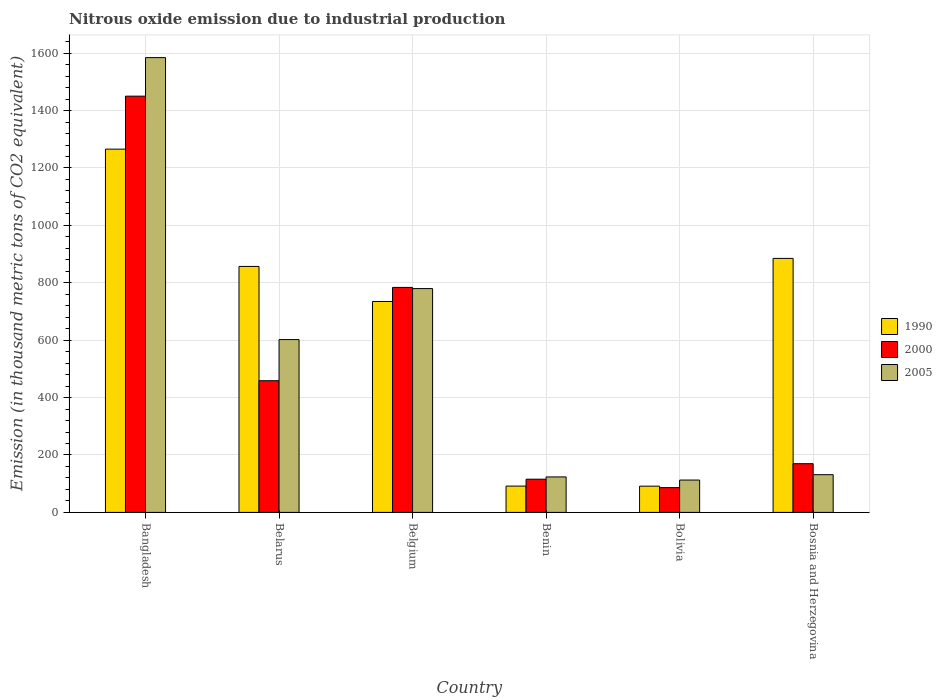Are the number of bars per tick equal to the number of legend labels?
Your answer should be compact. Yes. Are the number of bars on each tick of the X-axis equal?
Provide a short and direct response. Yes. How many bars are there on the 4th tick from the left?
Provide a short and direct response. 3. What is the amount of nitrous oxide emitted in 1990 in Bolivia?
Provide a succinct answer. 91.4. Across all countries, what is the maximum amount of nitrous oxide emitted in 2005?
Provide a short and direct response. 1584.6. Across all countries, what is the minimum amount of nitrous oxide emitted in 1990?
Your answer should be compact. 91.4. What is the total amount of nitrous oxide emitted in 2005 in the graph?
Your answer should be very brief. 3334.2. What is the difference between the amount of nitrous oxide emitted in 2000 in Bangladesh and that in Benin?
Your response must be concise. 1334.6. What is the difference between the amount of nitrous oxide emitted in 1990 in Bolivia and the amount of nitrous oxide emitted in 2000 in Bosnia and Herzegovina?
Offer a very short reply. -78.3. What is the average amount of nitrous oxide emitted in 2000 per country?
Keep it short and to the point. 510.78. What is the difference between the amount of nitrous oxide emitted of/in 1990 and amount of nitrous oxide emitted of/in 2000 in Benin?
Ensure brevity in your answer.  -24. In how many countries, is the amount of nitrous oxide emitted in 1990 greater than 1040 thousand metric tons?
Keep it short and to the point. 1. What is the ratio of the amount of nitrous oxide emitted in 1990 in Bangladesh to that in Belgium?
Provide a short and direct response. 1.72. Is the amount of nitrous oxide emitted in 1990 in Belarus less than that in Benin?
Offer a terse response. No. What is the difference between the highest and the second highest amount of nitrous oxide emitted in 2005?
Your answer should be very brief. 982.5. What is the difference between the highest and the lowest amount of nitrous oxide emitted in 1990?
Your answer should be compact. 1174.3. What does the 3rd bar from the left in Bangladesh represents?
Offer a very short reply. 2005. What does the 3rd bar from the right in Benin represents?
Your answer should be very brief. 1990. Are all the bars in the graph horizontal?
Keep it short and to the point. No. How many countries are there in the graph?
Offer a very short reply. 6. What is the difference between two consecutive major ticks on the Y-axis?
Offer a very short reply. 200. Where does the legend appear in the graph?
Your answer should be very brief. Center right. How many legend labels are there?
Provide a succinct answer. 3. How are the legend labels stacked?
Provide a short and direct response. Vertical. What is the title of the graph?
Provide a succinct answer. Nitrous oxide emission due to industrial production. What is the label or title of the Y-axis?
Provide a short and direct response. Emission (in thousand metric tons of CO2 equivalent). What is the Emission (in thousand metric tons of CO2 equivalent) of 1990 in Bangladesh?
Your answer should be compact. 1265.7. What is the Emission (in thousand metric tons of CO2 equivalent) in 2000 in Bangladesh?
Your answer should be very brief. 1450.3. What is the Emission (in thousand metric tons of CO2 equivalent) in 2005 in Bangladesh?
Offer a terse response. 1584.6. What is the Emission (in thousand metric tons of CO2 equivalent) in 1990 in Belarus?
Your response must be concise. 857. What is the Emission (in thousand metric tons of CO2 equivalent) of 2000 in Belarus?
Keep it short and to the point. 458.8. What is the Emission (in thousand metric tons of CO2 equivalent) in 2005 in Belarus?
Make the answer very short. 602.1. What is the Emission (in thousand metric tons of CO2 equivalent) in 1990 in Belgium?
Your response must be concise. 734.9. What is the Emission (in thousand metric tons of CO2 equivalent) of 2000 in Belgium?
Your answer should be very brief. 783.9. What is the Emission (in thousand metric tons of CO2 equivalent) of 2005 in Belgium?
Keep it short and to the point. 779.8. What is the Emission (in thousand metric tons of CO2 equivalent) in 1990 in Benin?
Provide a succinct answer. 91.7. What is the Emission (in thousand metric tons of CO2 equivalent) in 2000 in Benin?
Provide a succinct answer. 115.7. What is the Emission (in thousand metric tons of CO2 equivalent) in 2005 in Benin?
Your answer should be compact. 123.6. What is the Emission (in thousand metric tons of CO2 equivalent) of 1990 in Bolivia?
Provide a succinct answer. 91.4. What is the Emission (in thousand metric tons of CO2 equivalent) of 2000 in Bolivia?
Your response must be concise. 86.3. What is the Emission (in thousand metric tons of CO2 equivalent) in 2005 in Bolivia?
Give a very brief answer. 112.7. What is the Emission (in thousand metric tons of CO2 equivalent) in 1990 in Bosnia and Herzegovina?
Offer a terse response. 885. What is the Emission (in thousand metric tons of CO2 equivalent) in 2000 in Bosnia and Herzegovina?
Make the answer very short. 169.7. What is the Emission (in thousand metric tons of CO2 equivalent) of 2005 in Bosnia and Herzegovina?
Give a very brief answer. 131.4. Across all countries, what is the maximum Emission (in thousand metric tons of CO2 equivalent) of 1990?
Offer a terse response. 1265.7. Across all countries, what is the maximum Emission (in thousand metric tons of CO2 equivalent) of 2000?
Your answer should be very brief. 1450.3. Across all countries, what is the maximum Emission (in thousand metric tons of CO2 equivalent) in 2005?
Provide a succinct answer. 1584.6. Across all countries, what is the minimum Emission (in thousand metric tons of CO2 equivalent) of 1990?
Give a very brief answer. 91.4. Across all countries, what is the minimum Emission (in thousand metric tons of CO2 equivalent) in 2000?
Make the answer very short. 86.3. Across all countries, what is the minimum Emission (in thousand metric tons of CO2 equivalent) of 2005?
Offer a very short reply. 112.7. What is the total Emission (in thousand metric tons of CO2 equivalent) in 1990 in the graph?
Ensure brevity in your answer.  3925.7. What is the total Emission (in thousand metric tons of CO2 equivalent) of 2000 in the graph?
Your answer should be very brief. 3064.7. What is the total Emission (in thousand metric tons of CO2 equivalent) in 2005 in the graph?
Provide a succinct answer. 3334.2. What is the difference between the Emission (in thousand metric tons of CO2 equivalent) of 1990 in Bangladesh and that in Belarus?
Ensure brevity in your answer.  408.7. What is the difference between the Emission (in thousand metric tons of CO2 equivalent) in 2000 in Bangladesh and that in Belarus?
Make the answer very short. 991.5. What is the difference between the Emission (in thousand metric tons of CO2 equivalent) in 2005 in Bangladesh and that in Belarus?
Offer a terse response. 982.5. What is the difference between the Emission (in thousand metric tons of CO2 equivalent) of 1990 in Bangladesh and that in Belgium?
Make the answer very short. 530.8. What is the difference between the Emission (in thousand metric tons of CO2 equivalent) of 2000 in Bangladesh and that in Belgium?
Keep it short and to the point. 666.4. What is the difference between the Emission (in thousand metric tons of CO2 equivalent) in 2005 in Bangladesh and that in Belgium?
Your answer should be compact. 804.8. What is the difference between the Emission (in thousand metric tons of CO2 equivalent) in 1990 in Bangladesh and that in Benin?
Your response must be concise. 1174. What is the difference between the Emission (in thousand metric tons of CO2 equivalent) in 2000 in Bangladesh and that in Benin?
Keep it short and to the point. 1334.6. What is the difference between the Emission (in thousand metric tons of CO2 equivalent) of 2005 in Bangladesh and that in Benin?
Keep it short and to the point. 1461. What is the difference between the Emission (in thousand metric tons of CO2 equivalent) of 1990 in Bangladesh and that in Bolivia?
Ensure brevity in your answer.  1174.3. What is the difference between the Emission (in thousand metric tons of CO2 equivalent) in 2000 in Bangladesh and that in Bolivia?
Offer a very short reply. 1364. What is the difference between the Emission (in thousand metric tons of CO2 equivalent) in 2005 in Bangladesh and that in Bolivia?
Offer a very short reply. 1471.9. What is the difference between the Emission (in thousand metric tons of CO2 equivalent) in 1990 in Bangladesh and that in Bosnia and Herzegovina?
Ensure brevity in your answer.  380.7. What is the difference between the Emission (in thousand metric tons of CO2 equivalent) in 2000 in Bangladesh and that in Bosnia and Herzegovina?
Your answer should be compact. 1280.6. What is the difference between the Emission (in thousand metric tons of CO2 equivalent) of 2005 in Bangladesh and that in Bosnia and Herzegovina?
Provide a short and direct response. 1453.2. What is the difference between the Emission (in thousand metric tons of CO2 equivalent) of 1990 in Belarus and that in Belgium?
Give a very brief answer. 122.1. What is the difference between the Emission (in thousand metric tons of CO2 equivalent) in 2000 in Belarus and that in Belgium?
Your answer should be compact. -325.1. What is the difference between the Emission (in thousand metric tons of CO2 equivalent) in 2005 in Belarus and that in Belgium?
Provide a succinct answer. -177.7. What is the difference between the Emission (in thousand metric tons of CO2 equivalent) of 1990 in Belarus and that in Benin?
Provide a succinct answer. 765.3. What is the difference between the Emission (in thousand metric tons of CO2 equivalent) in 2000 in Belarus and that in Benin?
Provide a succinct answer. 343.1. What is the difference between the Emission (in thousand metric tons of CO2 equivalent) in 2005 in Belarus and that in Benin?
Make the answer very short. 478.5. What is the difference between the Emission (in thousand metric tons of CO2 equivalent) in 1990 in Belarus and that in Bolivia?
Your response must be concise. 765.6. What is the difference between the Emission (in thousand metric tons of CO2 equivalent) of 2000 in Belarus and that in Bolivia?
Give a very brief answer. 372.5. What is the difference between the Emission (in thousand metric tons of CO2 equivalent) in 2005 in Belarus and that in Bolivia?
Provide a short and direct response. 489.4. What is the difference between the Emission (in thousand metric tons of CO2 equivalent) of 1990 in Belarus and that in Bosnia and Herzegovina?
Ensure brevity in your answer.  -28. What is the difference between the Emission (in thousand metric tons of CO2 equivalent) of 2000 in Belarus and that in Bosnia and Herzegovina?
Your answer should be very brief. 289.1. What is the difference between the Emission (in thousand metric tons of CO2 equivalent) of 2005 in Belarus and that in Bosnia and Herzegovina?
Your response must be concise. 470.7. What is the difference between the Emission (in thousand metric tons of CO2 equivalent) of 1990 in Belgium and that in Benin?
Provide a succinct answer. 643.2. What is the difference between the Emission (in thousand metric tons of CO2 equivalent) in 2000 in Belgium and that in Benin?
Your answer should be compact. 668.2. What is the difference between the Emission (in thousand metric tons of CO2 equivalent) of 2005 in Belgium and that in Benin?
Provide a short and direct response. 656.2. What is the difference between the Emission (in thousand metric tons of CO2 equivalent) of 1990 in Belgium and that in Bolivia?
Your answer should be compact. 643.5. What is the difference between the Emission (in thousand metric tons of CO2 equivalent) of 2000 in Belgium and that in Bolivia?
Ensure brevity in your answer.  697.6. What is the difference between the Emission (in thousand metric tons of CO2 equivalent) in 2005 in Belgium and that in Bolivia?
Give a very brief answer. 667.1. What is the difference between the Emission (in thousand metric tons of CO2 equivalent) in 1990 in Belgium and that in Bosnia and Herzegovina?
Provide a succinct answer. -150.1. What is the difference between the Emission (in thousand metric tons of CO2 equivalent) of 2000 in Belgium and that in Bosnia and Herzegovina?
Offer a very short reply. 614.2. What is the difference between the Emission (in thousand metric tons of CO2 equivalent) in 2005 in Belgium and that in Bosnia and Herzegovina?
Give a very brief answer. 648.4. What is the difference between the Emission (in thousand metric tons of CO2 equivalent) in 2000 in Benin and that in Bolivia?
Offer a terse response. 29.4. What is the difference between the Emission (in thousand metric tons of CO2 equivalent) in 1990 in Benin and that in Bosnia and Herzegovina?
Ensure brevity in your answer.  -793.3. What is the difference between the Emission (in thousand metric tons of CO2 equivalent) of 2000 in Benin and that in Bosnia and Herzegovina?
Offer a very short reply. -54. What is the difference between the Emission (in thousand metric tons of CO2 equivalent) of 2005 in Benin and that in Bosnia and Herzegovina?
Provide a short and direct response. -7.8. What is the difference between the Emission (in thousand metric tons of CO2 equivalent) in 1990 in Bolivia and that in Bosnia and Herzegovina?
Your response must be concise. -793.6. What is the difference between the Emission (in thousand metric tons of CO2 equivalent) in 2000 in Bolivia and that in Bosnia and Herzegovina?
Provide a short and direct response. -83.4. What is the difference between the Emission (in thousand metric tons of CO2 equivalent) of 2005 in Bolivia and that in Bosnia and Herzegovina?
Keep it short and to the point. -18.7. What is the difference between the Emission (in thousand metric tons of CO2 equivalent) of 1990 in Bangladesh and the Emission (in thousand metric tons of CO2 equivalent) of 2000 in Belarus?
Make the answer very short. 806.9. What is the difference between the Emission (in thousand metric tons of CO2 equivalent) in 1990 in Bangladesh and the Emission (in thousand metric tons of CO2 equivalent) in 2005 in Belarus?
Your answer should be very brief. 663.6. What is the difference between the Emission (in thousand metric tons of CO2 equivalent) of 2000 in Bangladesh and the Emission (in thousand metric tons of CO2 equivalent) of 2005 in Belarus?
Your response must be concise. 848.2. What is the difference between the Emission (in thousand metric tons of CO2 equivalent) of 1990 in Bangladesh and the Emission (in thousand metric tons of CO2 equivalent) of 2000 in Belgium?
Ensure brevity in your answer.  481.8. What is the difference between the Emission (in thousand metric tons of CO2 equivalent) in 1990 in Bangladesh and the Emission (in thousand metric tons of CO2 equivalent) in 2005 in Belgium?
Ensure brevity in your answer.  485.9. What is the difference between the Emission (in thousand metric tons of CO2 equivalent) in 2000 in Bangladesh and the Emission (in thousand metric tons of CO2 equivalent) in 2005 in Belgium?
Your answer should be compact. 670.5. What is the difference between the Emission (in thousand metric tons of CO2 equivalent) of 1990 in Bangladesh and the Emission (in thousand metric tons of CO2 equivalent) of 2000 in Benin?
Your response must be concise. 1150. What is the difference between the Emission (in thousand metric tons of CO2 equivalent) of 1990 in Bangladesh and the Emission (in thousand metric tons of CO2 equivalent) of 2005 in Benin?
Make the answer very short. 1142.1. What is the difference between the Emission (in thousand metric tons of CO2 equivalent) in 2000 in Bangladesh and the Emission (in thousand metric tons of CO2 equivalent) in 2005 in Benin?
Your answer should be very brief. 1326.7. What is the difference between the Emission (in thousand metric tons of CO2 equivalent) of 1990 in Bangladesh and the Emission (in thousand metric tons of CO2 equivalent) of 2000 in Bolivia?
Make the answer very short. 1179.4. What is the difference between the Emission (in thousand metric tons of CO2 equivalent) of 1990 in Bangladesh and the Emission (in thousand metric tons of CO2 equivalent) of 2005 in Bolivia?
Provide a short and direct response. 1153. What is the difference between the Emission (in thousand metric tons of CO2 equivalent) in 2000 in Bangladesh and the Emission (in thousand metric tons of CO2 equivalent) in 2005 in Bolivia?
Provide a succinct answer. 1337.6. What is the difference between the Emission (in thousand metric tons of CO2 equivalent) of 1990 in Bangladesh and the Emission (in thousand metric tons of CO2 equivalent) of 2000 in Bosnia and Herzegovina?
Offer a terse response. 1096. What is the difference between the Emission (in thousand metric tons of CO2 equivalent) in 1990 in Bangladesh and the Emission (in thousand metric tons of CO2 equivalent) in 2005 in Bosnia and Herzegovina?
Ensure brevity in your answer.  1134.3. What is the difference between the Emission (in thousand metric tons of CO2 equivalent) in 2000 in Bangladesh and the Emission (in thousand metric tons of CO2 equivalent) in 2005 in Bosnia and Herzegovina?
Provide a short and direct response. 1318.9. What is the difference between the Emission (in thousand metric tons of CO2 equivalent) in 1990 in Belarus and the Emission (in thousand metric tons of CO2 equivalent) in 2000 in Belgium?
Offer a terse response. 73.1. What is the difference between the Emission (in thousand metric tons of CO2 equivalent) in 1990 in Belarus and the Emission (in thousand metric tons of CO2 equivalent) in 2005 in Belgium?
Your answer should be very brief. 77.2. What is the difference between the Emission (in thousand metric tons of CO2 equivalent) of 2000 in Belarus and the Emission (in thousand metric tons of CO2 equivalent) of 2005 in Belgium?
Your answer should be compact. -321. What is the difference between the Emission (in thousand metric tons of CO2 equivalent) in 1990 in Belarus and the Emission (in thousand metric tons of CO2 equivalent) in 2000 in Benin?
Provide a succinct answer. 741.3. What is the difference between the Emission (in thousand metric tons of CO2 equivalent) in 1990 in Belarus and the Emission (in thousand metric tons of CO2 equivalent) in 2005 in Benin?
Your answer should be compact. 733.4. What is the difference between the Emission (in thousand metric tons of CO2 equivalent) in 2000 in Belarus and the Emission (in thousand metric tons of CO2 equivalent) in 2005 in Benin?
Keep it short and to the point. 335.2. What is the difference between the Emission (in thousand metric tons of CO2 equivalent) of 1990 in Belarus and the Emission (in thousand metric tons of CO2 equivalent) of 2000 in Bolivia?
Keep it short and to the point. 770.7. What is the difference between the Emission (in thousand metric tons of CO2 equivalent) of 1990 in Belarus and the Emission (in thousand metric tons of CO2 equivalent) of 2005 in Bolivia?
Make the answer very short. 744.3. What is the difference between the Emission (in thousand metric tons of CO2 equivalent) in 2000 in Belarus and the Emission (in thousand metric tons of CO2 equivalent) in 2005 in Bolivia?
Ensure brevity in your answer.  346.1. What is the difference between the Emission (in thousand metric tons of CO2 equivalent) in 1990 in Belarus and the Emission (in thousand metric tons of CO2 equivalent) in 2000 in Bosnia and Herzegovina?
Offer a very short reply. 687.3. What is the difference between the Emission (in thousand metric tons of CO2 equivalent) of 1990 in Belarus and the Emission (in thousand metric tons of CO2 equivalent) of 2005 in Bosnia and Herzegovina?
Make the answer very short. 725.6. What is the difference between the Emission (in thousand metric tons of CO2 equivalent) of 2000 in Belarus and the Emission (in thousand metric tons of CO2 equivalent) of 2005 in Bosnia and Herzegovina?
Make the answer very short. 327.4. What is the difference between the Emission (in thousand metric tons of CO2 equivalent) of 1990 in Belgium and the Emission (in thousand metric tons of CO2 equivalent) of 2000 in Benin?
Ensure brevity in your answer.  619.2. What is the difference between the Emission (in thousand metric tons of CO2 equivalent) in 1990 in Belgium and the Emission (in thousand metric tons of CO2 equivalent) in 2005 in Benin?
Offer a terse response. 611.3. What is the difference between the Emission (in thousand metric tons of CO2 equivalent) of 2000 in Belgium and the Emission (in thousand metric tons of CO2 equivalent) of 2005 in Benin?
Provide a succinct answer. 660.3. What is the difference between the Emission (in thousand metric tons of CO2 equivalent) in 1990 in Belgium and the Emission (in thousand metric tons of CO2 equivalent) in 2000 in Bolivia?
Ensure brevity in your answer.  648.6. What is the difference between the Emission (in thousand metric tons of CO2 equivalent) of 1990 in Belgium and the Emission (in thousand metric tons of CO2 equivalent) of 2005 in Bolivia?
Ensure brevity in your answer.  622.2. What is the difference between the Emission (in thousand metric tons of CO2 equivalent) of 2000 in Belgium and the Emission (in thousand metric tons of CO2 equivalent) of 2005 in Bolivia?
Make the answer very short. 671.2. What is the difference between the Emission (in thousand metric tons of CO2 equivalent) in 1990 in Belgium and the Emission (in thousand metric tons of CO2 equivalent) in 2000 in Bosnia and Herzegovina?
Ensure brevity in your answer.  565.2. What is the difference between the Emission (in thousand metric tons of CO2 equivalent) in 1990 in Belgium and the Emission (in thousand metric tons of CO2 equivalent) in 2005 in Bosnia and Herzegovina?
Give a very brief answer. 603.5. What is the difference between the Emission (in thousand metric tons of CO2 equivalent) of 2000 in Belgium and the Emission (in thousand metric tons of CO2 equivalent) of 2005 in Bosnia and Herzegovina?
Offer a terse response. 652.5. What is the difference between the Emission (in thousand metric tons of CO2 equivalent) of 1990 in Benin and the Emission (in thousand metric tons of CO2 equivalent) of 2000 in Bosnia and Herzegovina?
Keep it short and to the point. -78. What is the difference between the Emission (in thousand metric tons of CO2 equivalent) of 1990 in Benin and the Emission (in thousand metric tons of CO2 equivalent) of 2005 in Bosnia and Herzegovina?
Offer a terse response. -39.7. What is the difference between the Emission (in thousand metric tons of CO2 equivalent) of 2000 in Benin and the Emission (in thousand metric tons of CO2 equivalent) of 2005 in Bosnia and Herzegovina?
Make the answer very short. -15.7. What is the difference between the Emission (in thousand metric tons of CO2 equivalent) in 1990 in Bolivia and the Emission (in thousand metric tons of CO2 equivalent) in 2000 in Bosnia and Herzegovina?
Offer a terse response. -78.3. What is the difference between the Emission (in thousand metric tons of CO2 equivalent) of 1990 in Bolivia and the Emission (in thousand metric tons of CO2 equivalent) of 2005 in Bosnia and Herzegovina?
Offer a very short reply. -40. What is the difference between the Emission (in thousand metric tons of CO2 equivalent) of 2000 in Bolivia and the Emission (in thousand metric tons of CO2 equivalent) of 2005 in Bosnia and Herzegovina?
Ensure brevity in your answer.  -45.1. What is the average Emission (in thousand metric tons of CO2 equivalent) in 1990 per country?
Make the answer very short. 654.28. What is the average Emission (in thousand metric tons of CO2 equivalent) of 2000 per country?
Offer a very short reply. 510.78. What is the average Emission (in thousand metric tons of CO2 equivalent) in 2005 per country?
Make the answer very short. 555.7. What is the difference between the Emission (in thousand metric tons of CO2 equivalent) in 1990 and Emission (in thousand metric tons of CO2 equivalent) in 2000 in Bangladesh?
Your response must be concise. -184.6. What is the difference between the Emission (in thousand metric tons of CO2 equivalent) in 1990 and Emission (in thousand metric tons of CO2 equivalent) in 2005 in Bangladesh?
Your answer should be very brief. -318.9. What is the difference between the Emission (in thousand metric tons of CO2 equivalent) of 2000 and Emission (in thousand metric tons of CO2 equivalent) of 2005 in Bangladesh?
Make the answer very short. -134.3. What is the difference between the Emission (in thousand metric tons of CO2 equivalent) of 1990 and Emission (in thousand metric tons of CO2 equivalent) of 2000 in Belarus?
Offer a terse response. 398.2. What is the difference between the Emission (in thousand metric tons of CO2 equivalent) in 1990 and Emission (in thousand metric tons of CO2 equivalent) in 2005 in Belarus?
Offer a terse response. 254.9. What is the difference between the Emission (in thousand metric tons of CO2 equivalent) in 2000 and Emission (in thousand metric tons of CO2 equivalent) in 2005 in Belarus?
Your response must be concise. -143.3. What is the difference between the Emission (in thousand metric tons of CO2 equivalent) of 1990 and Emission (in thousand metric tons of CO2 equivalent) of 2000 in Belgium?
Your answer should be compact. -49. What is the difference between the Emission (in thousand metric tons of CO2 equivalent) in 1990 and Emission (in thousand metric tons of CO2 equivalent) in 2005 in Belgium?
Make the answer very short. -44.9. What is the difference between the Emission (in thousand metric tons of CO2 equivalent) of 1990 and Emission (in thousand metric tons of CO2 equivalent) of 2000 in Benin?
Make the answer very short. -24. What is the difference between the Emission (in thousand metric tons of CO2 equivalent) in 1990 and Emission (in thousand metric tons of CO2 equivalent) in 2005 in Benin?
Your answer should be very brief. -31.9. What is the difference between the Emission (in thousand metric tons of CO2 equivalent) of 1990 and Emission (in thousand metric tons of CO2 equivalent) of 2005 in Bolivia?
Provide a short and direct response. -21.3. What is the difference between the Emission (in thousand metric tons of CO2 equivalent) of 2000 and Emission (in thousand metric tons of CO2 equivalent) of 2005 in Bolivia?
Ensure brevity in your answer.  -26.4. What is the difference between the Emission (in thousand metric tons of CO2 equivalent) in 1990 and Emission (in thousand metric tons of CO2 equivalent) in 2000 in Bosnia and Herzegovina?
Provide a succinct answer. 715.3. What is the difference between the Emission (in thousand metric tons of CO2 equivalent) of 1990 and Emission (in thousand metric tons of CO2 equivalent) of 2005 in Bosnia and Herzegovina?
Your answer should be very brief. 753.6. What is the difference between the Emission (in thousand metric tons of CO2 equivalent) in 2000 and Emission (in thousand metric tons of CO2 equivalent) in 2005 in Bosnia and Herzegovina?
Make the answer very short. 38.3. What is the ratio of the Emission (in thousand metric tons of CO2 equivalent) in 1990 in Bangladesh to that in Belarus?
Give a very brief answer. 1.48. What is the ratio of the Emission (in thousand metric tons of CO2 equivalent) of 2000 in Bangladesh to that in Belarus?
Offer a very short reply. 3.16. What is the ratio of the Emission (in thousand metric tons of CO2 equivalent) of 2005 in Bangladesh to that in Belarus?
Your answer should be compact. 2.63. What is the ratio of the Emission (in thousand metric tons of CO2 equivalent) in 1990 in Bangladesh to that in Belgium?
Ensure brevity in your answer.  1.72. What is the ratio of the Emission (in thousand metric tons of CO2 equivalent) in 2000 in Bangladesh to that in Belgium?
Offer a terse response. 1.85. What is the ratio of the Emission (in thousand metric tons of CO2 equivalent) of 2005 in Bangladesh to that in Belgium?
Your response must be concise. 2.03. What is the ratio of the Emission (in thousand metric tons of CO2 equivalent) of 1990 in Bangladesh to that in Benin?
Your response must be concise. 13.8. What is the ratio of the Emission (in thousand metric tons of CO2 equivalent) in 2000 in Bangladesh to that in Benin?
Provide a short and direct response. 12.54. What is the ratio of the Emission (in thousand metric tons of CO2 equivalent) in 2005 in Bangladesh to that in Benin?
Provide a succinct answer. 12.82. What is the ratio of the Emission (in thousand metric tons of CO2 equivalent) in 1990 in Bangladesh to that in Bolivia?
Ensure brevity in your answer.  13.85. What is the ratio of the Emission (in thousand metric tons of CO2 equivalent) of 2000 in Bangladesh to that in Bolivia?
Make the answer very short. 16.81. What is the ratio of the Emission (in thousand metric tons of CO2 equivalent) in 2005 in Bangladesh to that in Bolivia?
Provide a short and direct response. 14.06. What is the ratio of the Emission (in thousand metric tons of CO2 equivalent) of 1990 in Bangladesh to that in Bosnia and Herzegovina?
Ensure brevity in your answer.  1.43. What is the ratio of the Emission (in thousand metric tons of CO2 equivalent) of 2000 in Bangladesh to that in Bosnia and Herzegovina?
Ensure brevity in your answer.  8.55. What is the ratio of the Emission (in thousand metric tons of CO2 equivalent) in 2005 in Bangladesh to that in Bosnia and Herzegovina?
Offer a terse response. 12.06. What is the ratio of the Emission (in thousand metric tons of CO2 equivalent) in 1990 in Belarus to that in Belgium?
Offer a terse response. 1.17. What is the ratio of the Emission (in thousand metric tons of CO2 equivalent) of 2000 in Belarus to that in Belgium?
Offer a terse response. 0.59. What is the ratio of the Emission (in thousand metric tons of CO2 equivalent) in 2005 in Belarus to that in Belgium?
Ensure brevity in your answer.  0.77. What is the ratio of the Emission (in thousand metric tons of CO2 equivalent) of 1990 in Belarus to that in Benin?
Offer a very short reply. 9.35. What is the ratio of the Emission (in thousand metric tons of CO2 equivalent) of 2000 in Belarus to that in Benin?
Keep it short and to the point. 3.97. What is the ratio of the Emission (in thousand metric tons of CO2 equivalent) of 2005 in Belarus to that in Benin?
Ensure brevity in your answer.  4.87. What is the ratio of the Emission (in thousand metric tons of CO2 equivalent) in 1990 in Belarus to that in Bolivia?
Give a very brief answer. 9.38. What is the ratio of the Emission (in thousand metric tons of CO2 equivalent) in 2000 in Belarus to that in Bolivia?
Your response must be concise. 5.32. What is the ratio of the Emission (in thousand metric tons of CO2 equivalent) in 2005 in Belarus to that in Bolivia?
Your answer should be very brief. 5.34. What is the ratio of the Emission (in thousand metric tons of CO2 equivalent) of 1990 in Belarus to that in Bosnia and Herzegovina?
Ensure brevity in your answer.  0.97. What is the ratio of the Emission (in thousand metric tons of CO2 equivalent) of 2000 in Belarus to that in Bosnia and Herzegovina?
Your answer should be compact. 2.7. What is the ratio of the Emission (in thousand metric tons of CO2 equivalent) of 2005 in Belarus to that in Bosnia and Herzegovina?
Offer a terse response. 4.58. What is the ratio of the Emission (in thousand metric tons of CO2 equivalent) of 1990 in Belgium to that in Benin?
Keep it short and to the point. 8.01. What is the ratio of the Emission (in thousand metric tons of CO2 equivalent) in 2000 in Belgium to that in Benin?
Provide a short and direct response. 6.78. What is the ratio of the Emission (in thousand metric tons of CO2 equivalent) of 2005 in Belgium to that in Benin?
Give a very brief answer. 6.31. What is the ratio of the Emission (in thousand metric tons of CO2 equivalent) in 1990 in Belgium to that in Bolivia?
Give a very brief answer. 8.04. What is the ratio of the Emission (in thousand metric tons of CO2 equivalent) in 2000 in Belgium to that in Bolivia?
Provide a succinct answer. 9.08. What is the ratio of the Emission (in thousand metric tons of CO2 equivalent) in 2005 in Belgium to that in Bolivia?
Offer a terse response. 6.92. What is the ratio of the Emission (in thousand metric tons of CO2 equivalent) in 1990 in Belgium to that in Bosnia and Herzegovina?
Offer a very short reply. 0.83. What is the ratio of the Emission (in thousand metric tons of CO2 equivalent) in 2000 in Belgium to that in Bosnia and Herzegovina?
Your answer should be compact. 4.62. What is the ratio of the Emission (in thousand metric tons of CO2 equivalent) of 2005 in Belgium to that in Bosnia and Herzegovina?
Your response must be concise. 5.93. What is the ratio of the Emission (in thousand metric tons of CO2 equivalent) in 2000 in Benin to that in Bolivia?
Your response must be concise. 1.34. What is the ratio of the Emission (in thousand metric tons of CO2 equivalent) of 2005 in Benin to that in Bolivia?
Offer a terse response. 1.1. What is the ratio of the Emission (in thousand metric tons of CO2 equivalent) of 1990 in Benin to that in Bosnia and Herzegovina?
Your answer should be compact. 0.1. What is the ratio of the Emission (in thousand metric tons of CO2 equivalent) of 2000 in Benin to that in Bosnia and Herzegovina?
Your answer should be compact. 0.68. What is the ratio of the Emission (in thousand metric tons of CO2 equivalent) of 2005 in Benin to that in Bosnia and Herzegovina?
Offer a very short reply. 0.94. What is the ratio of the Emission (in thousand metric tons of CO2 equivalent) in 1990 in Bolivia to that in Bosnia and Herzegovina?
Provide a succinct answer. 0.1. What is the ratio of the Emission (in thousand metric tons of CO2 equivalent) of 2000 in Bolivia to that in Bosnia and Herzegovina?
Ensure brevity in your answer.  0.51. What is the ratio of the Emission (in thousand metric tons of CO2 equivalent) of 2005 in Bolivia to that in Bosnia and Herzegovina?
Offer a very short reply. 0.86. What is the difference between the highest and the second highest Emission (in thousand metric tons of CO2 equivalent) in 1990?
Give a very brief answer. 380.7. What is the difference between the highest and the second highest Emission (in thousand metric tons of CO2 equivalent) of 2000?
Ensure brevity in your answer.  666.4. What is the difference between the highest and the second highest Emission (in thousand metric tons of CO2 equivalent) of 2005?
Provide a short and direct response. 804.8. What is the difference between the highest and the lowest Emission (in thousand metric tons of CO2 equivalent) in 1990?
Give a very brief answer. 1174.3. What is the difference between the highest and the lowest Emission (in thousand metric tons of CO2 equivalent) in 2000?
Keep it short and to the point. 1364. What is the difference between the highest and the lowest Emission (in thousand metric tons of CO2 equivalent) in 2005?
Offer a very short reply. 1471.9. 